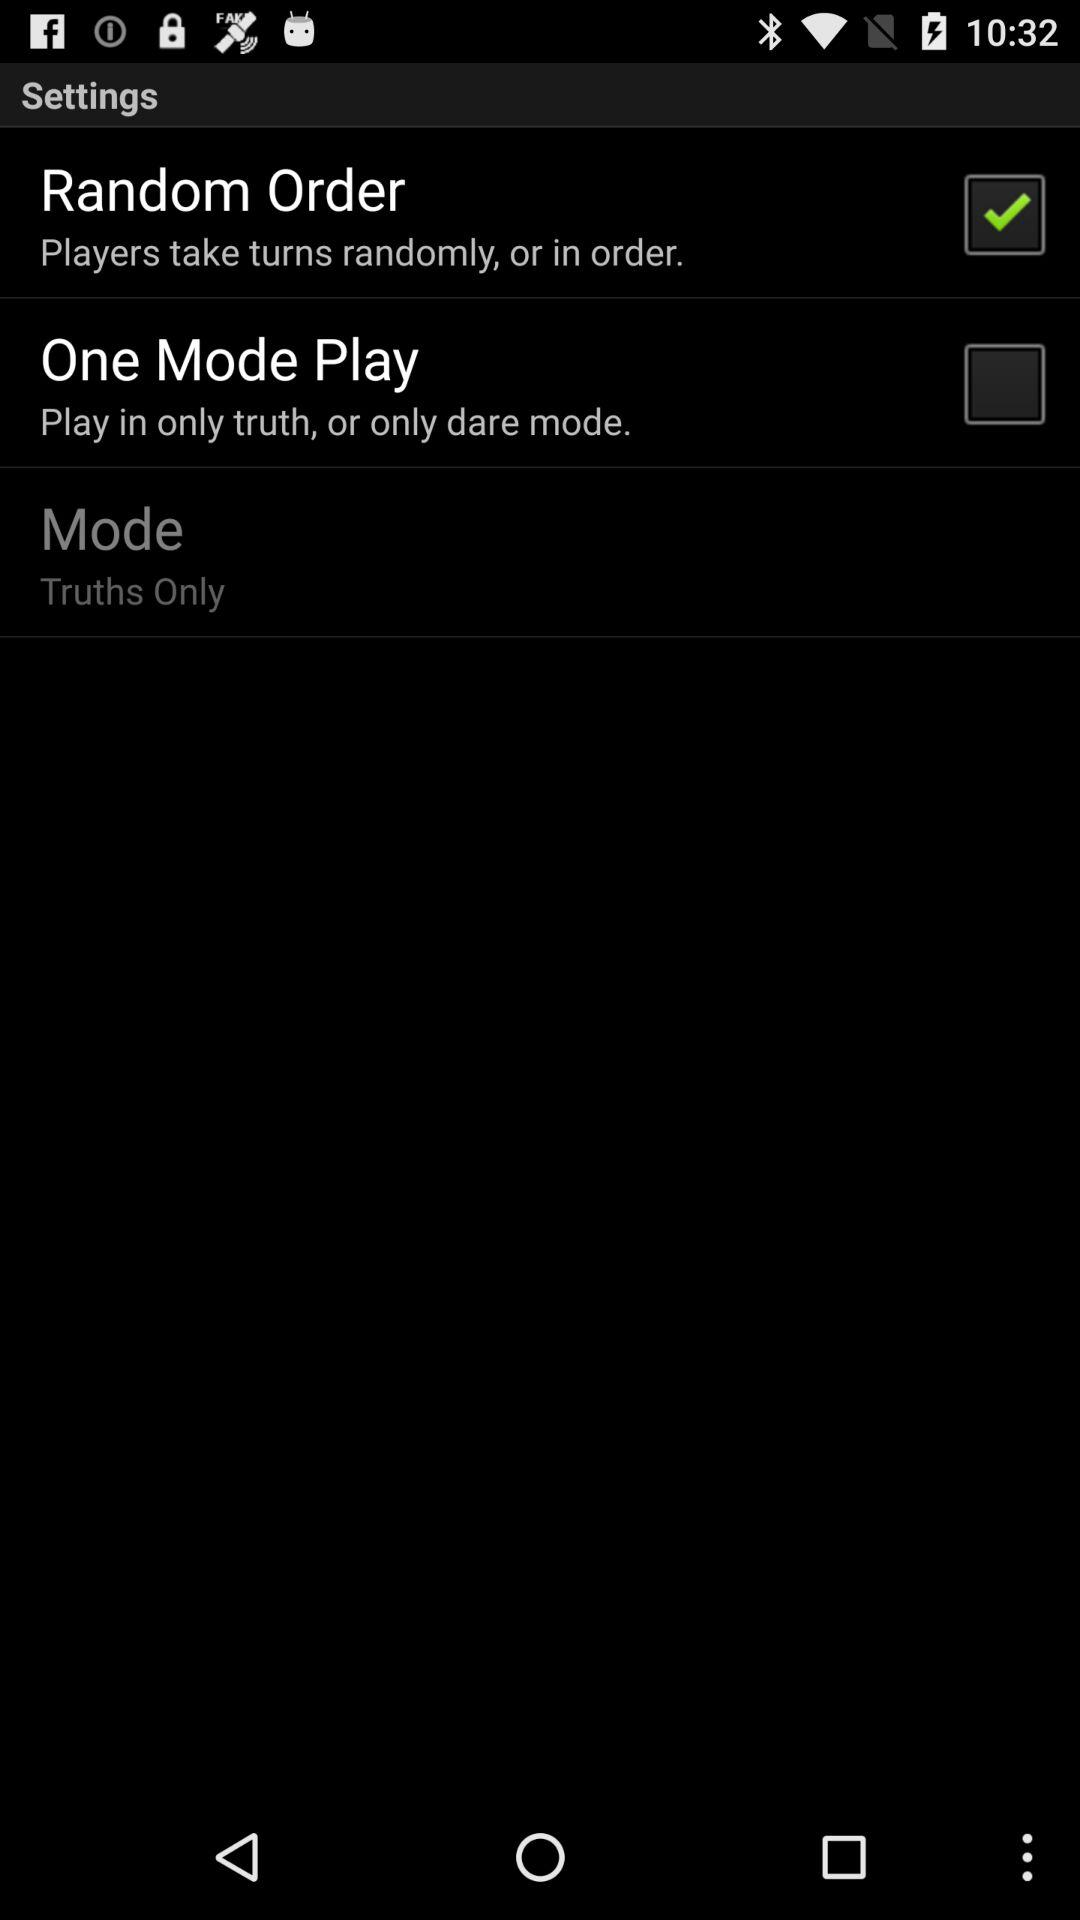What's the status of the "Random Order"? The status is "on". 